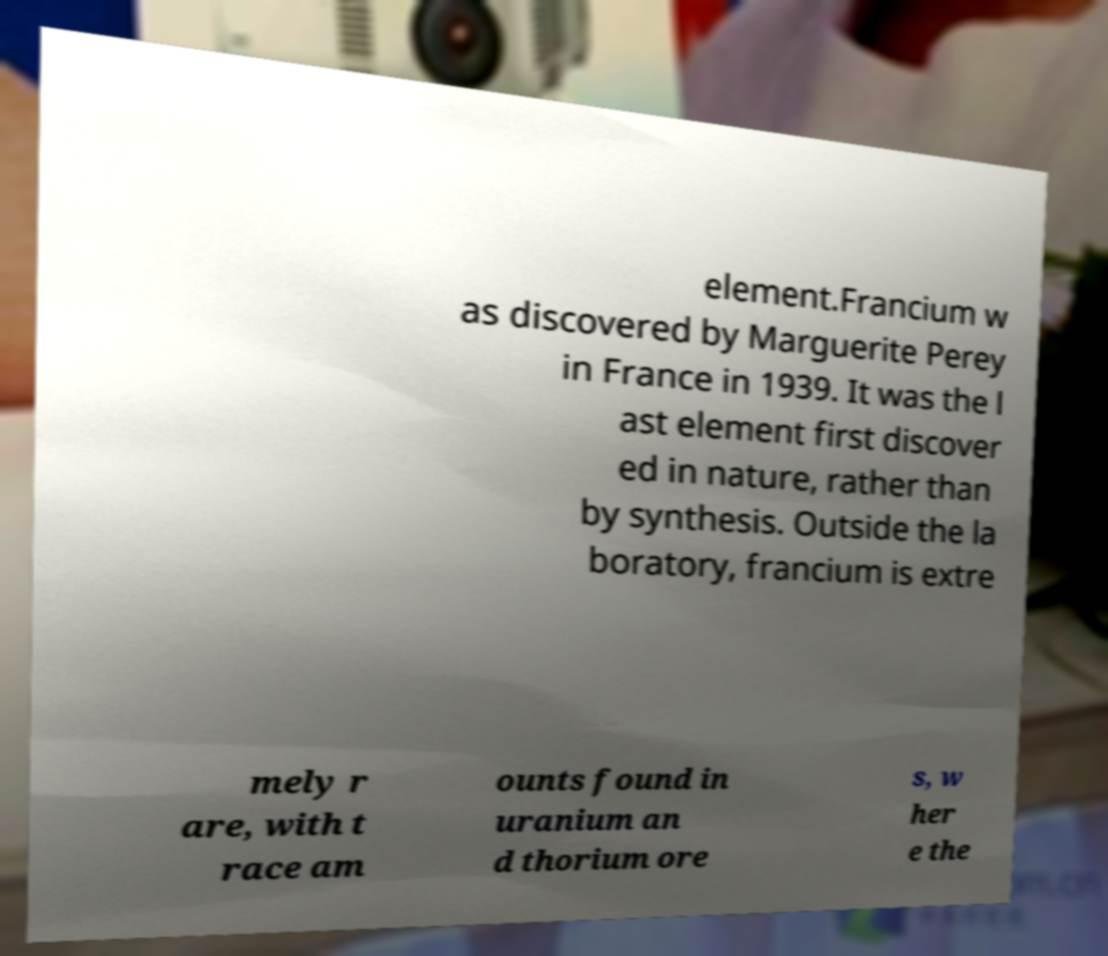There's text embedded in this image that I need extracted. Can you transcribe it verbatim? element.Francium w as discovered by Marguerite Perey in France in 1939. It was the l ast element first discover ed in nature, rather than by synthesis. Outside the la boratory, francium is extre mely r are, with t race am ounts found in uranium an d thorium ore s, w her e the 